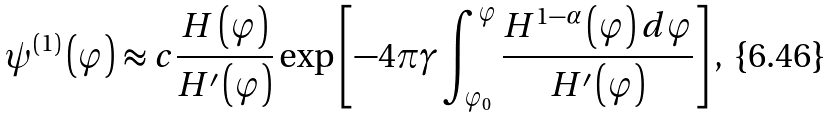Convert formula to latex. <formula><loc_0><loc_0><loc_500><loc_500>\psi ^ { \left ( 1 \right ) } \left ( \varphi \right ) \approx c \frac { H \left ( \varphi \right ) } { H ^ { \prime } \left ( \varphi \right ) } \exp \left [ - 4 \pi \gamma \int _ { \varphi _ { 0 } } ^ { \varphi } \frac { H ^ { 1 - \alpha } \left ( \varphi \right ) d \varphi } { H ^ { \prime } \left ( \varphi \right ) } \right ] ,</formula> 